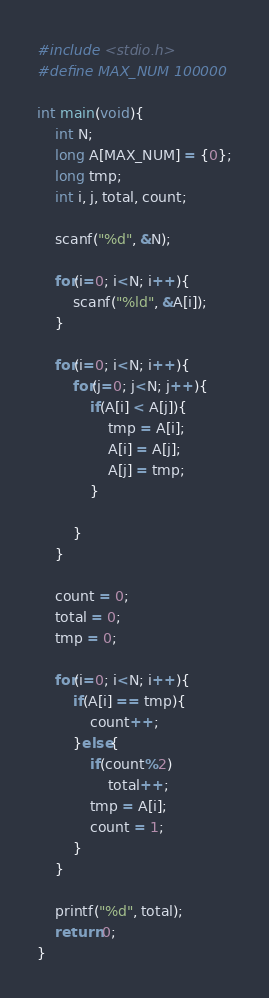<code> <loc_0><loc_0><loc_500><loc_500><_C_>#include <stdio.h>
#define MAX_NUM 100000

int main(void){
	int N;
	long A[MAX_NUM] = {0};
	long tmp;
	int i, j, total, count;

	scanf("%d", &N);

	for(i=0; i<N; i++){
		scanf("%ld", &A[i]);
	}

	for(i=0; i<N; i++){
		for(j=0; j<N; j++){
			if(A[i] < A[j]){
				tmp = A[i];
				A[i] = A[j];
				A[j] = tmp;
			}

		}
	}

	count = 0;
	total = 0;
	tmp = 0;

	for(i=0; i<N; i++){
		if(A[i] == tmp){
			count++;
		}else{
			if(count%2)
				total++;
			tmp = A[i];
			count = 1;
		}
	}

	printf("%d", total);
	return 0;
}</code> 